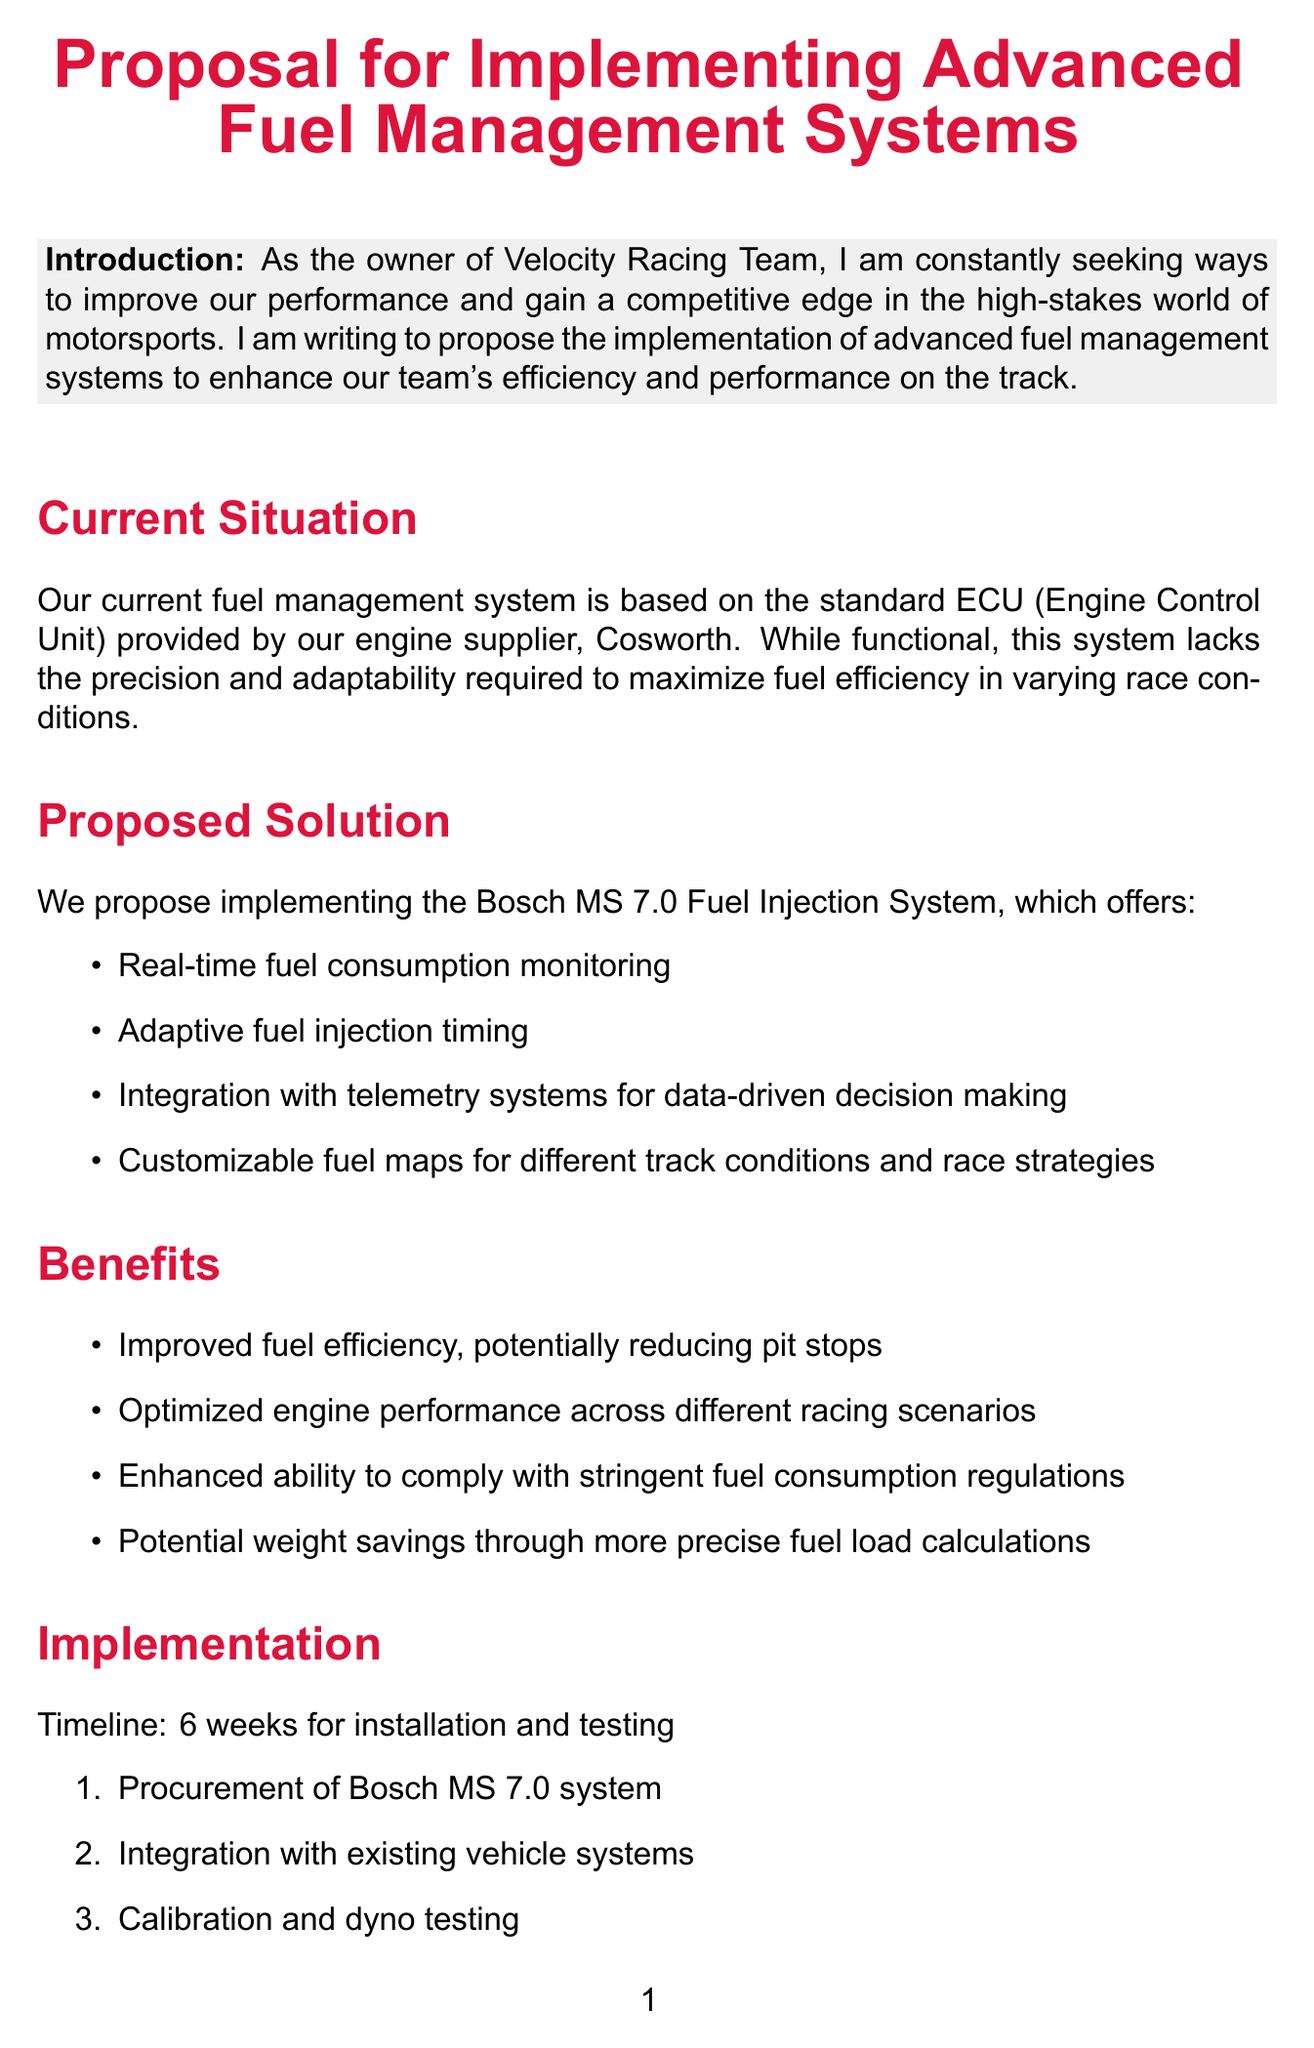What is the proposed system? The document mentions that the proposed system for fuel management is the Bosch MS 7.0 Fuel Injection System.
Answer: Bosch MS 7.0 Fuel Injection System What is the estimated initial investment? The initial investment for hardware and installation is provided in the document.
Answer: $75,000 How long is the implementation timeline? The document specifies the timeline for installation and testing of the new system.
Answer: 6 weeks What is one feature of the Bosch MS 7.0 system? The document lists several features of the system, including real-time fuel consumption monitoring.
Answer: Real-time fuel consumption monitoring What competitive advantage do we aim to gain? The document discusses how implementing the system will help us align with leading teams.
Answer: Edge over mid-field competitors What is the estimated percentage improvement in fuel efficiency? The projected savings section of the document provides an estimate for improvement in fuel efficiency.
Answer: 3-5% What is the main purpose of the letter? The introduction of the document states the intention behind writing this proposal.
Answer: To enhance our team's efficiency and performance on the track What is one potential benefit of the proposed system? Various benefits are outlined in the document, one of which is improved fuel efficiency.
Answer: Improved fuel efficiency What is the call to action? The conclusion of the document urges a specific action from the reader regarding the proposal.
Answer: Provide your expert opinion on its potential impact on our race strategy and overall team performance 